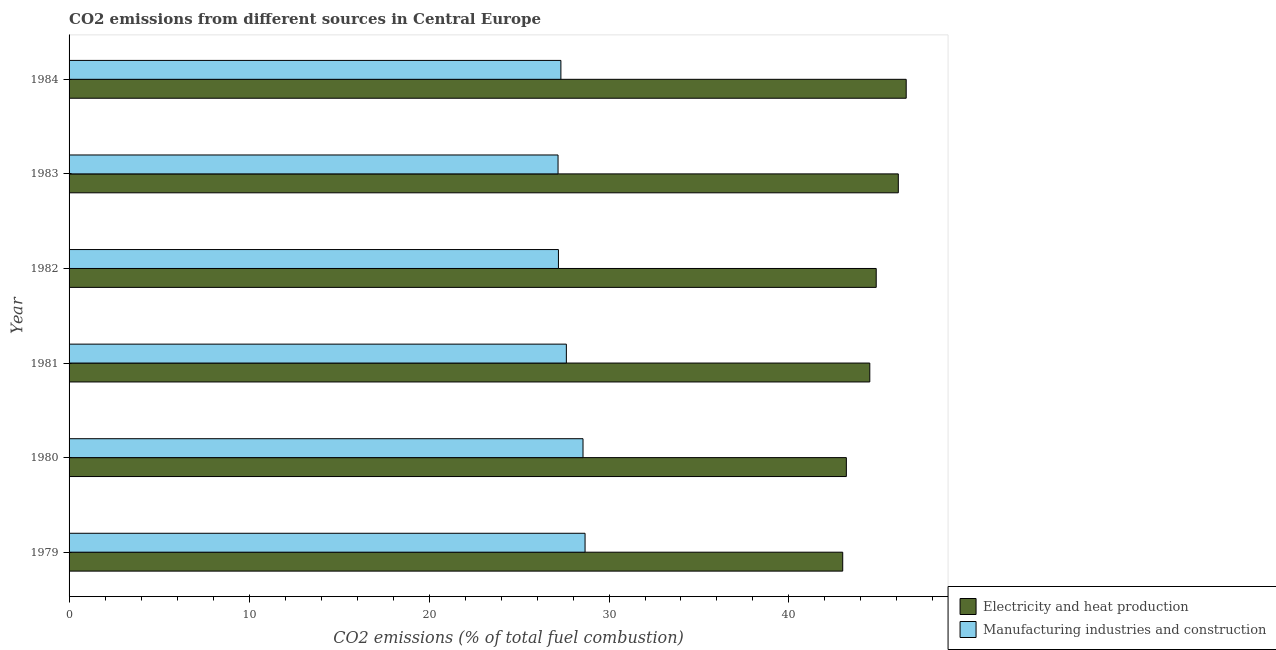How many different coloured bars are there?
Provide a short and direct response. 2. Are the number of bars per tick equal to the number of legend labels?
Your response must be concise. Yes. Are the number of bars on each tick of the Y-axis equal?
Keep it short and to the point. Yes. What is the label of the 2nd group of bars from the top?
Give a very brief answer. 1983. What is the co2 emissions due to electricity and heat production in 1984?
Ensure brevity in your answer.  46.51. Across all years, what is the maximum co2 emissions due to manufacturing industries?
Offer a very short reply. 28.67. Across all years, what is the minimum co2 emissions due to manufacturing industries?
Ensure brevity in your answer.  27.17. In which year was the co2 emissions due to manufacturing industries maximum?
Keep it short and to the point. 1979. In which year was the co2 emissions due to electricity and heat production minimum?
Your answer should be very brief. 1979. What is the total co2 emissions due to manufacturing industries in the graph?
Provide a short and direct response. 166.54. What is the difference between the co2 emissions due to manufacturing industries in 1980 and that in 1983?
Give a very brief answer. 1.39. What is the difference between the co2 emissions due to electricity and heat production in 1979 and the co2 emissions due to manufacturing industries in 1982?
Provide a succinct answer. 15.8. What is the average co2 emissions due to electricity and heat production per year?
Make the answer very short. 44.68. In the year 1980, what is the difference between the co2 emissions due to electricity and heat production and co2 emissions due to manufacturing industries?
Make the answer very short. 14.63. Is the co2 emissions due to manufacturing industries in 1980 less than that in 1981?
Ensure brevity in your answer.  No. What is the difference between the highest and the second highest co2 emissions due to electricity and heat production?
Your answer should be compact. 0.44. What is the difference between the highest and the lowest co2 emissions due to electricity and heat production?
Your answer should be compact. 3.53. In how many years, is the co2 emissions due to electricity and heat production greater than the average co2 emissions due to electricity and heat production taken over all years?
Make the answer very short. 3. Is the sum of the co2 emissions due to electricity and heat production in 1983 and 1984 greater than the maximum co2 emissions due to manufacturing industries across all years?
Give a very brief answer. Yes. What does the 2nd bar from the top in 1982 represents?
Keep it short and to the point. Electricity and heat production. What does the 1st bar from the bottom in 1984 represents?
Offer a very short reply. Electricity and heat production. Are all the bars in the graph horizontal?
Your answer should be compact. Yes. What is the difference between two consecutive major ticks on the X-axis?
Provide a short and direct response. 10. Are the values on the major ticks of X-axis written in scientific E-notation?
Offer a very short reply. No. Where does the legend appear in the graph?
Provide a short and direct response. Bottom right. How are the legend labels stacked?
Your answer should be compact. Vertical. What is the title of the graph?
Your answer should be very brief. CO2 emissions from different sources in Central Europe. What is the label or title of the X-axis?
Ensure brevity in your answer.  CO2 emissions (% of total fuel combustion). What is the label or title of the Y-axis?
Offer a very short reply. Year. What is the CO2 emissions (% of total fuel combustion) in Electricity and heat production in 1979?
Offer a very short reply. 42.99. What is the CO2 emissions (% of total fuel combustion) of Manufacturing industries and construction in 1979?
Keep it short and to the point. 28.67. What is the CO2 emissions (% of total fuel combustion) of Electricity and heat production in 1980?
Offer a very short reply. 43.19. What is the CO2 emissions (% of total fuel combustion) of Manufacturing industries and construction in 1980?
Keep it short and to the point. 28.56. What is the CO2 emissions (% of total fuel combustion) in Electricity and heat production in 1981?
Ensure brevity in your answer.  44.49. What is the CO2 emissions (% of total fuel combustion) in Manufacturing industries and construction in 1981?
Ensure brevity in your answer.  27.63. What is the CO2 emissions (% of total fuel combustion) in Electricity and heat production in 1982?
Make the answer very short. 44.85. What is the CO2 emissions (% of total fuel combustion) of Manufacturing industries and construction in 1982?
Your answer should be compact. 27.19. What is the CO2 emissions (% of total fuel combustion) of Electricity and heat production in 1983?
Offer a terse response. 46.08. What is the CO2 emissions (% of total fuel combustion) of Manufacturing industries and construction in 1983?
Make the answer very short. 27.17. What is the CO2 emissions (% of total fuel combustion) in Electricity and heat production in 1984?
Make the answer very short. 46.51. What is the CO2 emissions (% of total fuel combustion) of Manufacturing industries and construction in 1984?
Make the answer very short. 27.33. Across all years, what is the maximum CO2 emissions (% of total fuel combustion) in Electricity and heat production?
Give a very brief answer. 46.51. Across all years, what is the maximum CO2 emissions (% of total fuel combustion) of Manufacturing industries and construction?
Ensure brevity in your answer.  28.67. Across all years, what is the minimum CO2 emissions (% of total fuel combustion) in Electricity and heat production?
Give a very brief answer. 42.99. Across all years, what is the minimum CO2 emissions (% of total fuel combustion) of Manufacturing industries and construction?
Make the answer very short. 27.17. What is the total CO2 emissions (% of total fuel combustion) in Electricity and heat production in the graph?
Give a very brief answer. 268.1. What is the total CO2 emissions (% of total fuel combustion) of Manufacturing industries and construction in the graph?
Your answer should be compact. 166.54. What is the difference between the CO2 emissions (% of total fuel combustion) of Electricity and heat production in 1979 and that in 1980?
Ensure brevity in your answer.  -0.2. What is the difference between the CO2 emissions (% of total fuel combustion) of Manufacturing industries and construction in 1979 and that in 1980?
Provide a succinct answer. 0.11. What is the difference between the CO2 emissions (% of total fuel combustion) in Electricity and heat production in 1979 and that in 1981?
Provide a succinct answer. -1.5. What is the difference between the CO2 emissions (% of total fuel combustion) of Manufacturing industries and construction in 1979 and that in 1981?
Your answer should be compact. 1.04. What is the difference between the CO2 emissions (% of total fuel combustion) in Electricity and heat production in 1979 and that in 1982?
Keep it short and to the point. -1.86. What is the difference between the CO2 emissions (% of total fuel combustion) of Manufacturing industries and construction in 1979 and that in 1982?
Your answer should be compact. 1.48. What is the difference between the CO2 emissions (% of total fuel combustion) in Electricity and heat production in 1979 and that in 1983?
Your answer should be very brief. -3.09. What is the difference between the CO2 emissions (% of total fuel combustion) of Manufacturing industries and construction in 1979 and that in 1983?
Provide a short and direct response. 1.5. What is the difference between the CO2 emissions (% of total fuel combustion) in Electricity and heat production in 1979 and that in 1984?
Offer a very short reply. -3.53. What is the difference between the CO2 emissions (% of total fuel combustion) of Manufacturing industries and construction in 1979 and that in 1984?
Provide a succinct answer. 1.34. What is the difference between the CO2 emissions (% of total fuel combustion) in Electricity and heat production in 1980 and that in 1981?
Make the answer very short. -1.3. What is the difference between the CO2 emissions (% of total fuel combustion) in Manufacturing industries and construction in 1980 and that in 1981?
Your response must be concise. 0.93. What is the difference between the CO2 emissions (% of total fuel combustion) in Electricity and heat production in 1980 and that in 1982?
Your response must be concise. -1.66. What is the difference between the CO2 emissions (% of total fuel combustion) of Manufacturing industries and construction in 1980 and that in 1982?
Ensure brevity in your answer.  1.37. What is the difference between the CO2 emissions (% of total fuel combustion) in Electricity and heat production in 1980 and that in 1983?
Offer a very short reply. -2.89. What is the difference between the CO2 emissions (% of total fuel combustion) in Manufacturing industries and construction in 1980 and that in 1983?
Keep it short and to the point. 1.39. What is the difference between the CO2 emissions (% of total fuel combustion) of Electricity and heat production in 1980 and that in 1984?
Make the answer very short. -3.33. What is the difference between the CO2 emissions (% of total fuel combustion) of Manufacturing industries and construction in 1980 and that in 1984?
Keep it short and to the point. 1.23. What is the difference between the CO2 emissions (% of total fuel combustion) in Electricity and heat production in 1981 and that in 1982?
Your answer should be compact. -0.36. What is the difference between the CO2 emissions (% of total fuel combustion) of Manufacturing industries and construction in 1981 and that in 1982?
Offer a very short reply. 0.44. What is the difference between the CO2 emissions (% of total fuel combustion) of Electricity and heat production in 1981 and that in 1983?
Make the answer very short. -1.58. What is the difference between the CO2 emissions (% of total fuel combustion) of Manufacturing industries and construction in 1981 and that in 1983?
Ensure brevity in your answer.  0.46. What is the difference between the CO2 emissions (% of total fuel combustion) of Electricity and heat production in 1981 and that in 1984?
Your answer should be very brief. -2.02. What is the difference between the CO2 emissions (% of total fuel combustion) in Manufacturing industries and construction in 1981 and that in 1984?
Provide a succinct answer. 0.3. What is the difference between the CO2 emissions (% of total fuel combustion) of Electricity and heat production in 1982 and that in 1983?
Your answer should be compact. -1.23. What is the difference between the CO2 emissions (% of total fuel combustion) in Manufacturing industries and construction in 1982 and that in 1983?
Provide a succinct answer. 0.02. What is the difference between the CO2 emissions (% of total fuel combustion) of Electricity and heat production in 1982 and that in 1984?
Your response must be concise. -1.67. What is the difference between the CO2 emissions (% of total fuel combustion) in Manufacturing industries and construction in 1982 and that in 1984?
Give a very brief answer. -0.14. What is the difference between the CO2 emissions (% of total fuel combustion) in Electricity and heat production in 1983 and that in 1984?
Provide a short and direct response. -0.44. What is the difference between the CO2 emissions (% of total fuel combustion) of Manufacturing industries and construction in 1983 and that in 1984?
Provide a succinct answer. -0.16. What is the difference between the CO2 emissions (% of total fuel combustion) in Electricity and heat production in 1979 and the CO2 emissions (% of total fuel combustion) in Manufacturing industries and construction in 1980?
Your answer should be very brief. 14.43. What is the difference between the CO2 emissions (% of total fuel combustion) of Electricity and heat production in 1979 and the CO2 emissions (% of total fuel combustion) of Manufacturing industries and construction in 1981?
Provide a short and direct response. 15.36. What is the difference between the CO2 emissions (% of total fuel combustion) of Electricity and heat production in 1979 and the CO2 emissions (% of total fuel combustion) of Manufacturing industries and construction in 1982?
Give a very brief answer. 15.8. What is the difference between the CO2 emissions (% of total fuel combustion) in Electricity and heat production in 1979 and the CO2 emissions (% of total fuel combustion) in Manufacturing industries and construction in 1983?
Offer a very short reply. 15.82. What is the difference between the CO2 emissions (% of total fuel combustion) of Electricity and heat production in 1979 and the CO2 emissions (% of total fuel combustion) of Manufacturing industries and construction in 1984?
Ensure brevity in your answer.  15.66. What is the difference between the CO2 emissions (% of total fuel combustion) in Electricity and heat production in 1980 and the CO2 emissions (% of total fuel combustion) in Manufacturing industries and construction in 1981?
Provide a succinct answer. 15.56. What is the difference between the CO2 emissions (% of total fuel combustion) of Electricity and heat production in 1980 and the CO2 emissions (% of total fuel combustion) of Manufacturing industries and construction in 1982?
Keep it short and to the point. 16. What is the difference between the CO2 emissions (% of total fuel combustion) of Electricity and heat production in 1980 and the CO2 emissions (% of total fuel combustion) of Manufacturing industries and construction in 1983?
Offer a very short reply. 16.02. What is the difference between the CO2 emissions (% of total fuel combustion) in Electricity and heat production in 1980 and the CO2 emissions (% of total fuel combustion) in Manufacturing industries and construction in 1984?
Offer a very short reply. 15.86. What is the difference between the CO2 emissions (% of total fuel combustion) of Electricity and heat production in 1981 and the CO2 emissions (% of total fuel combustion) of Manufacturing industries and construction in 1983?
Provide a short and direct response. 17.32. What is the difference between the CO2 emissions (% of total fuel combustion) of Electricity and heat production in 1981 and the CO2 emissions (% of total fuel combustion) of Manufacturing industries and construction in 1984?
Give a very brief answer. 17.16. What is the difference between the CO2 emissions (% of total fuel combustion) in Electricity and heat production in 1982 and the CO2 emissions (% of total fuel combustion) in Manufacturing industries and construction in 1983?
Ensure brevity in your answer.  17.68. What is the difference between the CO2 emissions (% of total fuel combustion) in Electricity and heat production in 1982 and the CO2 emissions (% of total fuel combustion) in Manufacturing industries and construction in 1984?
Your response must be concise. 17.52. What is the difference between the CO2 emissions (% of total fuel combustion) in Electricity and heat production in 1983 and the CO2 emissions (% of total fuel combustion) in Manufacturing industries and construction in 1984?
Give a very brief answer. 18.75. What is the average CO2 emissions (% of total fuel combustion) in Electricity and heat production per year?
Ensure brevity in your answer.  44.68. What is the average CO2 emissions (% of total fuel combustion) in Manufacturing industries and construction per year?
Make the answer very short. 27.76. In the year 1979, what is the difference between the CO2 emissions (% of total fuel combustion) of Electricity and heat production and CO2 emissions (% of total fuel combustion) of Manufacturing industries and construction?
Your answer should be very brief. 14.32. In the year 1980, what is the difference between the CO2 emissions (% of total fuel combustion) in Electricity and heat production and CO2 emissions (% of total fuel combustion) in Manufacturing industries and construction?
Your answer should be very brief. 14.63. In the year 1981, what is the difference between the CO2 emissions (% of total fuel combustion) of Electricity and heat production and CO2 emissions (% of total fuel combustion) of Manufacturing industries and construction?
Offer a very short reply. 16.86. In the year 1982, what is the difference between the CO2 emissions (% of total fuel combustion) in Electricity and heat production and CO2 emissions (% of total fuel combustion) in Manufacturing industries and construction?
Keep it short and to the point. 17.66. In the year 1983, what is the difference between the CO2 emissions (% of total fuel combustion) of Electricity and heat production and CO2 emissions (% of total fuel combustion) of Manufacturing industries and construction?
Provide a short and direct response. 18.91. In the year 1984, what is the difference between the CO2 emissions (% of total fuel combustion) in Electricity and heat production and CO2 emissions (% of total fuel combustion) in Manufacturing industries and construction?
Your response must be concise. 19.19. What is the ratio of the CO2 emissions (% of total fuel combustion) of Manufacturing industries and construction in 1979 to that in 1980?
Offer a terse response. 1. What is the ratio of the CO2 emissions (% of total fuel combustion) of Electricity and heat production in 1979 to that in 1981?
Your response must be concise. 0.97. What is the ratio of the CO2 emissions (% of total fuel combustion) in Manufacturing industries and construction in 1979 to that in 1981?
Provide a short and direct response. 1.04. What is the ratio of the CO2 emissions (% of total fuel combustion) in Electricity and heat production in 1979 to that in 1982?
Make the answer very short. 0.96. What is the ratio of the CO2 emissions (% of total fuel combustion) of Manufacturing industries and construction in 1979 to that in 1982?
Provide a short and direct response. 1.05. What is the ratio of the CO2 emissions (% of total fuel combustion) in Electricity and heat production in 1979 to that in 1983?
Make the answer very short. 0.93. What is the ratio of the CO2 emissions (% of total fuel combustion) of Manufacturing industries and construction in 1979 to that in 1983?
Provide a short and direct response. 1.06. What is the ratio of the CO2 emissions (% of total fuel combustion) of Electricity and heat production in 1979 to that in 1984?
Make the answer very short. 0.92. What is the ratio of the CO2 emissions (% of total fuel combustion) of Manufacturing industries and construction in 1979 to that in 1984?
Offer a very short reply. 1.05. What is the ratio of the CO2 emissions (% of total fuel combustion) in Electricity and heat production in 1980 to that in 1981?
Your response must be concise. 0.97. What is the ratio of the CO2 emissions (% of total fuel combustion) of Manufacturing industries and construction in 1980 to that in 1981?
Ensure brevity in your answer.  1.03. What is the ratio of the CO2 emissions (% of total fuel combustion) in Electricity and heat production in 1980 to that in 1982?
Your answer should be compact. 0.96. What is the ratio of the CO2 emissions (% of total fuel combustion) in Manufacturing industries and construction in 1980 to that in 1982?
Make the answer very short. 1.05. What is the ratio of the CO2 emissions (% of total fuel combustion) of Electricity and heat production in 1980 to that in 1983?
Make the answer very short. 0.94. What is the ratio of the CO2 emissions (% of total fuel combustion) in Manufacturing industries and construction in 1980 to that in 1983?
Keep it short and to the point. 1.05. What is the ratio of the CO2 emissions (% of total fuel combustion) of Electricity and heat production in 1980 to that in 1984?
Offer a terse response. 0.93. What is the ratio of the CO2 emissions (% of total fuel combustion) in Manufacturing industries and construction in 1980 to that in 1984?
Keep it short and to the point. 1.04. What is the ratio of the CO2 emissions (% of total fuel combustion) of Manufacturing industries and construction in 1981 to that in 1982?
Offer a very short reply. 1.02. What is the ratio of the CO2 emissions (% of total fuel combustion) of Electricity and heat production in 1981 to that in 1983?
Ensure brevity in your answer.  0.97. What is the ratio of the CO2 emissions (% of total fuel combustion) of Manufacturing industries and construction in 1981 to that in 1983?
Your answer should be very brief. 1.02. What is the ratio of the CO2 emissions (% of total fuel combustion) in Electricity and heat production in 1981 to that in 1984?
Your response must be concise. 0.96. What is the ratio of the CO2 emissions (% of total fuel combustion) of Manufacturing industries and construction in 1981 to that in 1984?
Keep it short and to the point. 1.01. What is the ratio of the CO2 emissions (% of total fuel combustion) of Electricity and heat production in 1982 to that in 1983?
Keep it short and to the point. 0.97. What is the ratio of the CO2 emissions (% of total fuel combustion) of Electricity and heat production in 1982 to that in 1984?
Your answer should be compact. 0.96. What is the ratio of the CO2 emissions (% of total fuel combustion) in Manufacturing industries and construction in 1982 to that in 1984?
Offer a terse response. 0.99. What is the ratio of the CO2 emissions (% of total fuel combustion) of Electricity and heat production in 1983 to that in 1984?
Your answer should be compact. 0.99. What is the difference between the highest and the second highest CO2 emissions (% of total fuel combustion) in Electricity and heat production?
Your answer should be very brief. 0.44. What is the difference between the highest and the second highest CO2 emissions (% of total fuel combustion) of Manufacturing industries and construction?
Give a very brief answer. 0.11. What is the difference between the highest and the lowest CO2 emissions (% of total fuel combustion) of Electricity and heat production?
Ensure brevity in your answer.  3.53. What is the difference between the highest and the lowest CO2 emissions (% of total fuel combustion) of Manufacturing industries and construction?
Give a very brief answer. 1.5. 